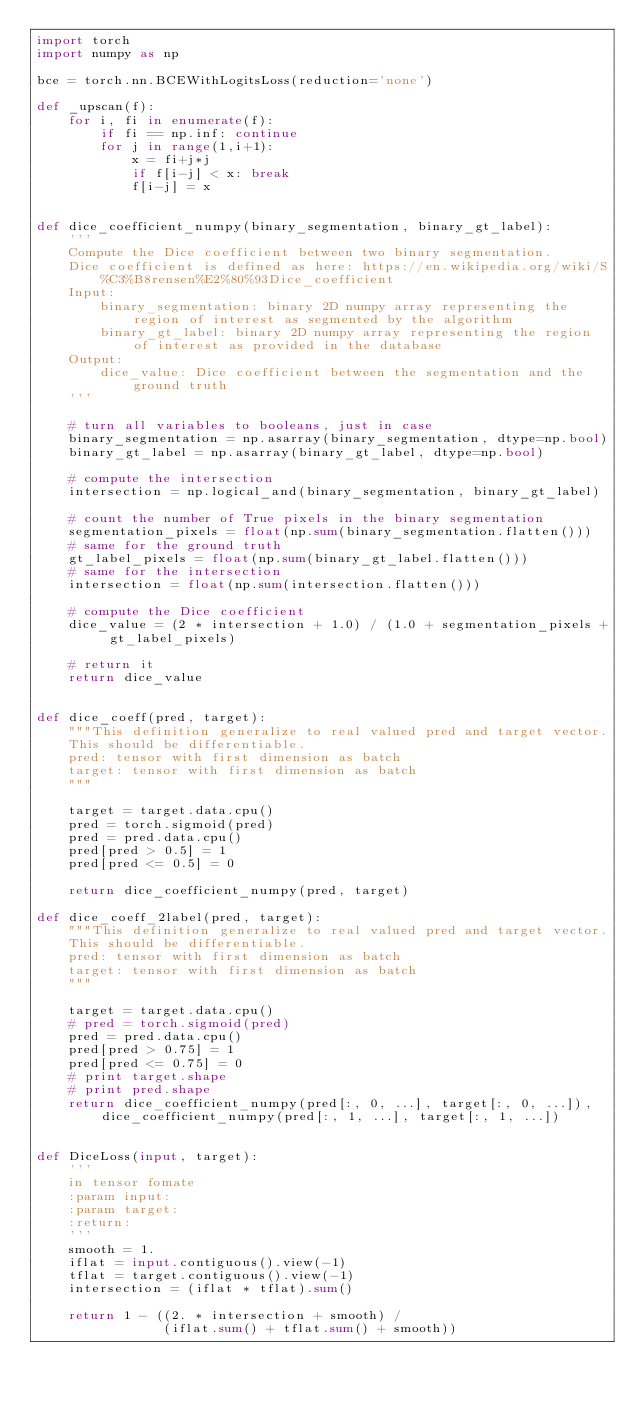<code> <loc_0><loc_0><loc_500><loc_500><_Python_>import torch
import numpy as np

bce = torch.nn.BCEWithLogitsLoss(reduction='none')

def _upscan(f):
    for i, fi in enumerate(f):
        if fi == np.inf: continue
        for j in range(1,i+1):
            x = fi+j*j
            if f[i-j] < x: break
            f[i-j] = x


def dice_coefficient_numpy(binary_segmentation, binary_gt_label):
    '''
    Compute the Dice coefficient between two binary segmentation.
    Dice coefficient is defined as here: https://en.wikipedia.org/wiki/S%C3%B8rensen%E2%80%93Dice_coefficient
    Input:
        binary_segmentation: binary 2D numpy array representing the region of interest as segmented by the algorithm
        binary_gt_label: binary 2D numpy array representing the region of interest as provided in the database
    Output:
        dice_value: Dice coefficient between the segmentation and the ground truth
    '''

    # turn all variables to booleans, just in case
    binary_segmentation = np.asarray(binary_segmentation, dtype=np.bool)
    binary_gt_label = np.asarray(binary_gt_label, dtype=np.bool)

    # compute the intersection
    intersection = np.logical_and(binary_segmentation, binary_gt_label)

    # count the number of True pixels in the binary segmentation
    segmentation_pixels = float(np.sum(binary_segmentation.flatten()))
    # same for the ground truth
    gt_label_pixels = float(np.sum(binary_gt_label.flatten()))
    # same for the intersection
    intersection = float(np.sum(intersection.flatten()))

    # compute the Dice coefficient
    dice_value = (2 * intersection + 1.0) / (1.0 + segmentation_pixels + gt_label_pixels)

    # return it
    return dice_value


def dice_coeff(pred, target):
    """This definition generalize to real valued pred and target vector.
    This should be differentiable.
    pred: tensor with first dimension as batch
    target: tensor with first dimension as batch
    """

    target = target.data.cpu()
    pred = torch.sigmoid(pred)
    pred = pred.data.cpu()
    pred[pred > 0.5] = 1
    pred[pred <= 0.5] = 0

    return dice_coefficient_numpy(pred, target)

def dice_coeff_2label(pred, target):
    """This definition generalize to real valued pred and target vector.
    This should be differentiable.
    pred: tensor with first dimension as batch
    target: tensor with first dimension as batch
    """

    target = target.data.cpu()
    # pred = torch.sigmoid(pred)
    pred = pred.data.cpu()
    pred[pred > 0.75] = 1
    pred[pred <= 0.75] = 0
    # print target.shape
    # print pred.shape
    return dice_coefficient_numpy(pred[:, 0, ...], target[:, 0, ...]), dice_coefficient_numpy(pred[:, 1, ...], target[:, 1, ...])


def DiceLoss(input, target):
    '''
    in tensor fomate
    :param input:
    :param target:
    :return:
    '''
    smooth = 1.
    iflat = input.contiguous().view(-1)
    tflat = target.contiguous().view(-1)
    intersection = (iflat * tflat).sum()

    return 1 - ((2. * intersection + smooth) /
                (iflat.sum() + tflat.sum() + smooth))
</code> 